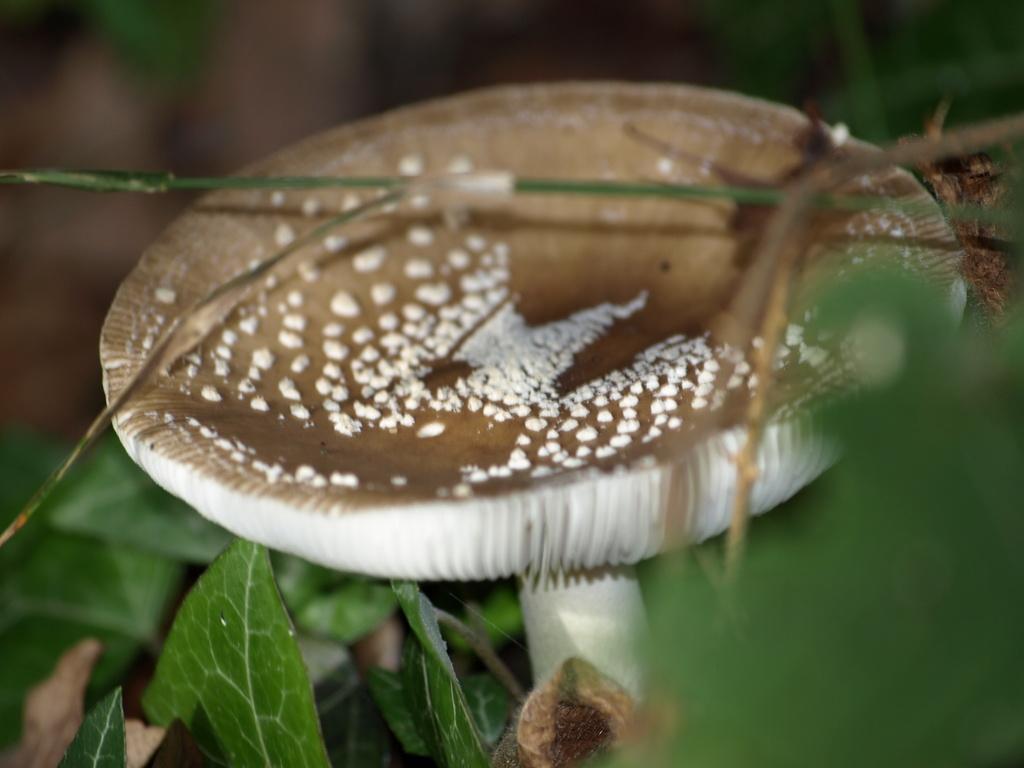Could you give a brief overview of what you see in this image? In this image there is a mushroom. Bottom of the image there are few plants having leaves. 